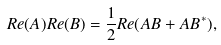<formula> <loc_0><loc_0><loc_500><loc_500>R e ( A ) R e ( B ) = \frac { 1 } { 2 } R e ( A B + A B ^ { * } ) ,</formula> 